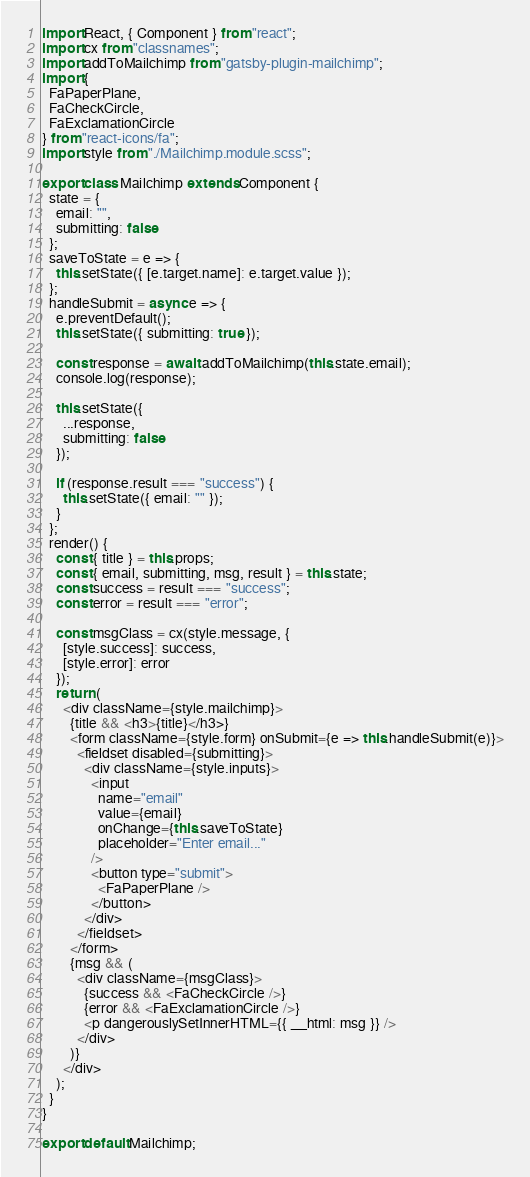Convert code to text. <code><loc_0><loc_0><loc_500><loc_500><_JavaScript_>import React, { Component } from "react";
import cx from "classnames";
import addToMailchimp from "gatsby-plugin-mailchimp";
import {
  FaPaperPlane,
  FaCheckCircle,
  FaExclamationCircle
} from "react-icons/fa";
import style from "./Mailchimp.module.scss";

export class Mailchimp extends Component {
  state = {
    email: "",
    submitting: false
  };
  saveToState = e => {
    this.setState({ [e.target.name]: e.target.value });
  };
  handleSubmit = async e => {
    e.preventDefault();
    this.setState({ submitting: true });

    const response = await addToMailchimp(this.state.email);
    console.log(response);

    this.setState({
      ...response,
      submitting: false
    });

    if (response.result === "success") {
      this.setState({ email: "" });
    }
  };
  render() {
    const { title } = this.props;
    const { email, submitting, msg, result } = this.state;
    const success = result === "success";
    const error = result === "error";

    const msgClass = cx(style.message, {
      [style.success]: success,
      [style.error]: error
    });
    return (
      <div className={style.mailchimp}>
        {title && <h3>{title}</h3>}
        <form className={style.form} onSubmit={e => this.handleSubmit(e)}>
          <fieldset disabled={submitting}>
            <div className={style.inputs}>
              <input
                name="email"
                value={email}
                onChange={this.saveToState}
                placeholder="Enter email..."
              />
              <button type="submit">
                <FaPaperPlane />
              </button>
            </div>
          </fieldset>
        </form>
        {msg && (
          <div className={msgClass}>
            {success && <FaCheckCircle />}
            {error && <FaExclamationCircle />}
            <p dangerouslySetInnerHTML={{ __html: msg }} />
          </div>
        )}
      </div>
    );
  }
}

export default Mailchimp;
</code> 